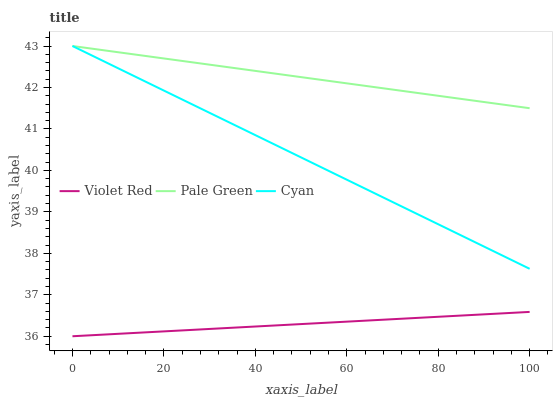Does Violet Red have the minimum area under the curve?
Answer yes or no. Yes. Does Pale Green have the maximum area under the curve?
Answer yes or no. Yes. Does Pale Green have the minimum area under the curve?
Answer yes or no. No. Does Violet Red have the maximum area under the curve?
Answer yes or no. No. Is Pale Green the smoothest?
Answer yes or no. Yes. Is Violet Red the roughest?
Answer yes or no. Yes. Is Violet Red the smoothest?
Answer yes or no. No. Is Pale Green the roughest?
Answer yes or no. No. Does Violet Red have the lowest value?
Answer yes or no. Yes. Does Pale Green have the lowest value?
Answer yes or no. No. Does Pale Green have the highest value?
Answer yes or no. Yes. Does Violet Red have the highest value?
Answer yes or no. No. Is Violet Red less than Cyan?
Answer yes or no. Yes. Is Cyan greater than Violet Red?
Answer yes or no. Yes. Does Pale Green intersect Cyan?
Answer yes or no. Yes. Is Pale Green less than Cyan?
Answer yes or no. No. Is Pale Green greater than Cyan?
Answer yes or no. No. Does Violet Red intersect Cyan?
Answer yes or no. No. 